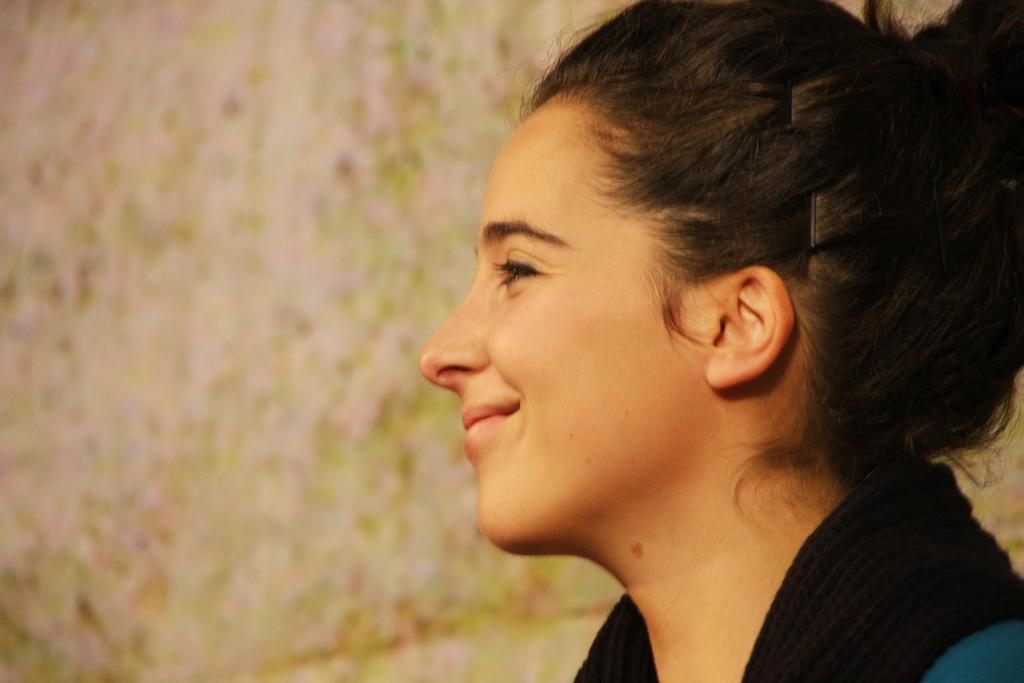Who is present in the image? There is a woman in the image. What is the woman's expression in the image? The woman is smiling in the image. What time of day is it on Earth in the image? The image does not provide any information about the time of day or the location on Earth, so it cannot be determined from the image. 